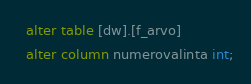Convert code to text. <code><loc_0><loc_0><loc_500><loc_500><_SQL_>  alter table [dw].[f_arvo]
  alter column numerovalinta int;</code> 